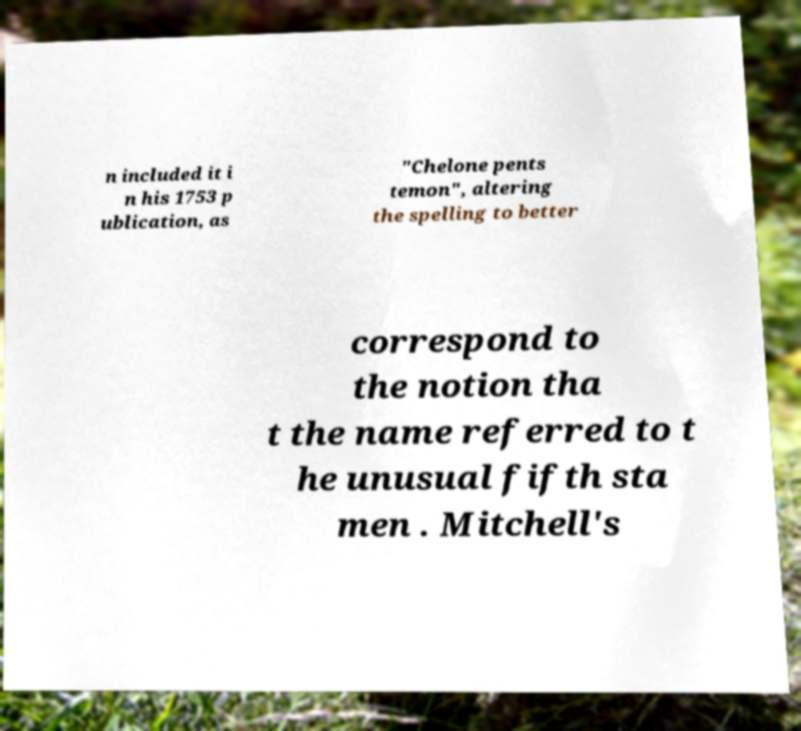Please identify and transcribe the text found in this image. n included it i n his 1753 p ublication, as "Chelone pents temon", altering the spelling to better correspond to the notion tha t the name referred to t he unusual fifth sta men . Mitchell's 